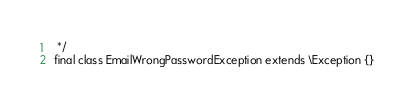Convert code to text. <code><loc_0><loc_0><loc_500><loc_500><_PHP_> */
final class EmailWrongPasswordException extends \Exception {}</code> 